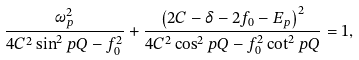Convert formula to latex. <formula><loc_0><loc_0><loc_500><loc_500>\frac { \omega _ { p } ^ { 2 } } { 4 C ^ { 2 } \sin ^ { 2 } p Q - f _ { 0 } ^ { 2 } } + \frac { \left ( 2 C - \delta - 2 f _ { 0 } - E _ { p } \right ) ^ { 2 } } { 4 C ^ { 2 } \cos ^ { 2 } p Q - f _ { 0 } ^ { 2 } \cot ^ { 2 } p Q } = 1 ,</formula> 